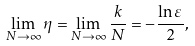<formula> <loc_0><loc_0><loc_500><loc_500>\lim _ { N \to \infty } \eta = \lim _ { N \to \infty } \frac { k } { N } = - \frac { \ln \varepsilon } { 2 } ,</formula> 